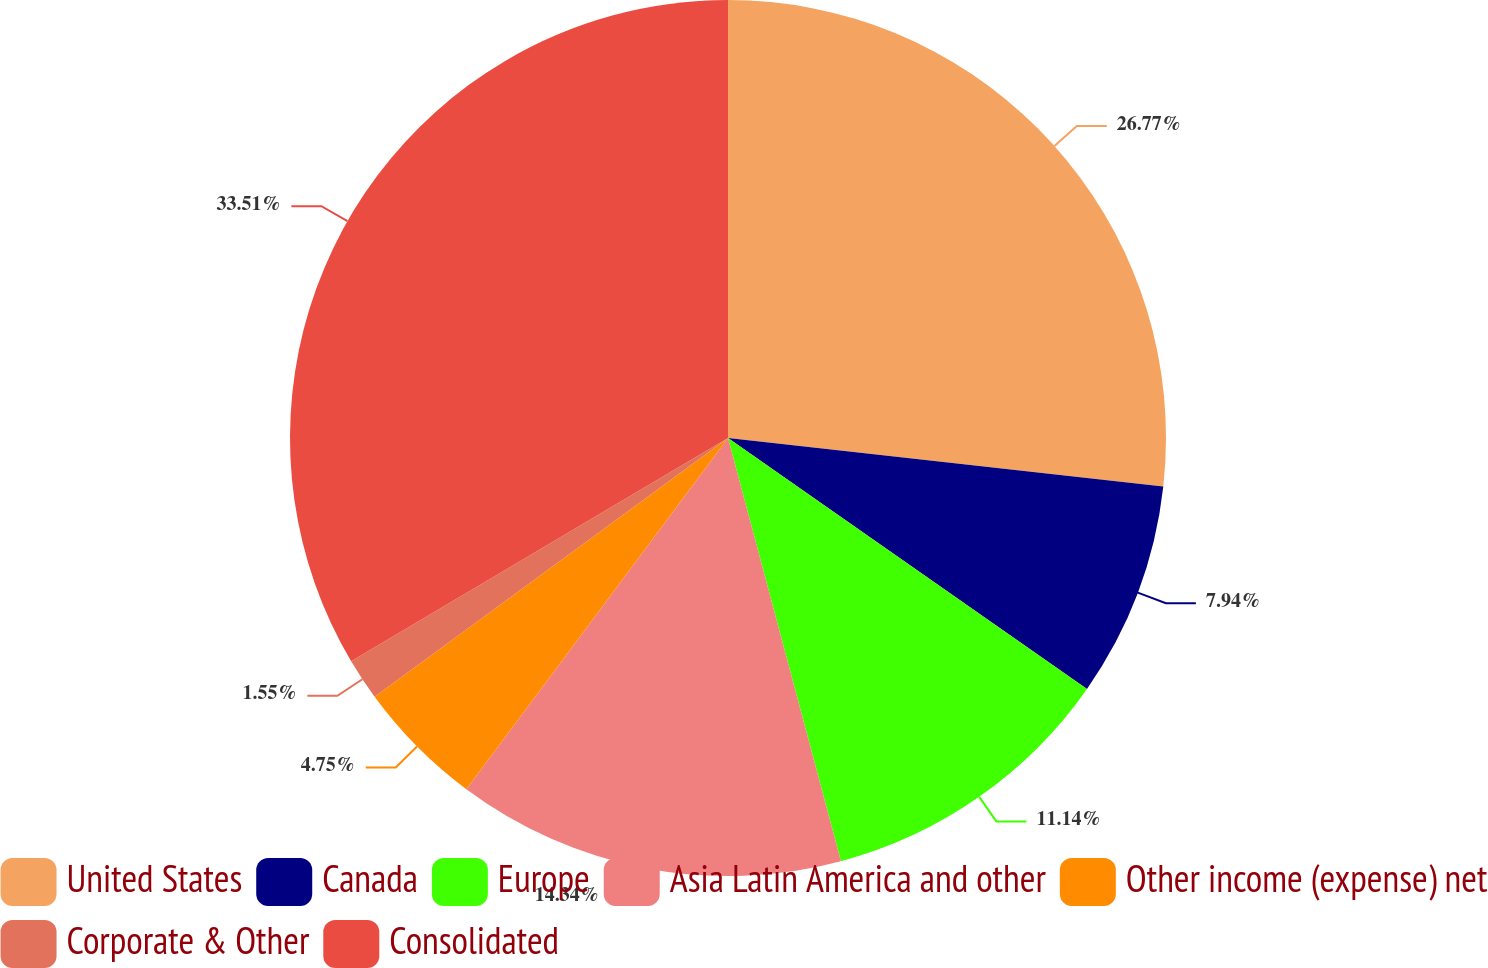Convert chart to OTSL. <chart><loc_0><loc_0><loc_500><loc_500><pie_chart><fcel>United States<fcel>Canada<fcel>Europe<fcel>Asia Latin America and other<fcel>Other income (expense) net<fcel>Corporate & Other<fcel>Consolidated<nl><fcel>26.77%<fcel>7.94%<fcel>11.14%<fcel>14.34%<fcel>4.75%<fcel>1.55%<fcel>33.51%<nl></chart> 